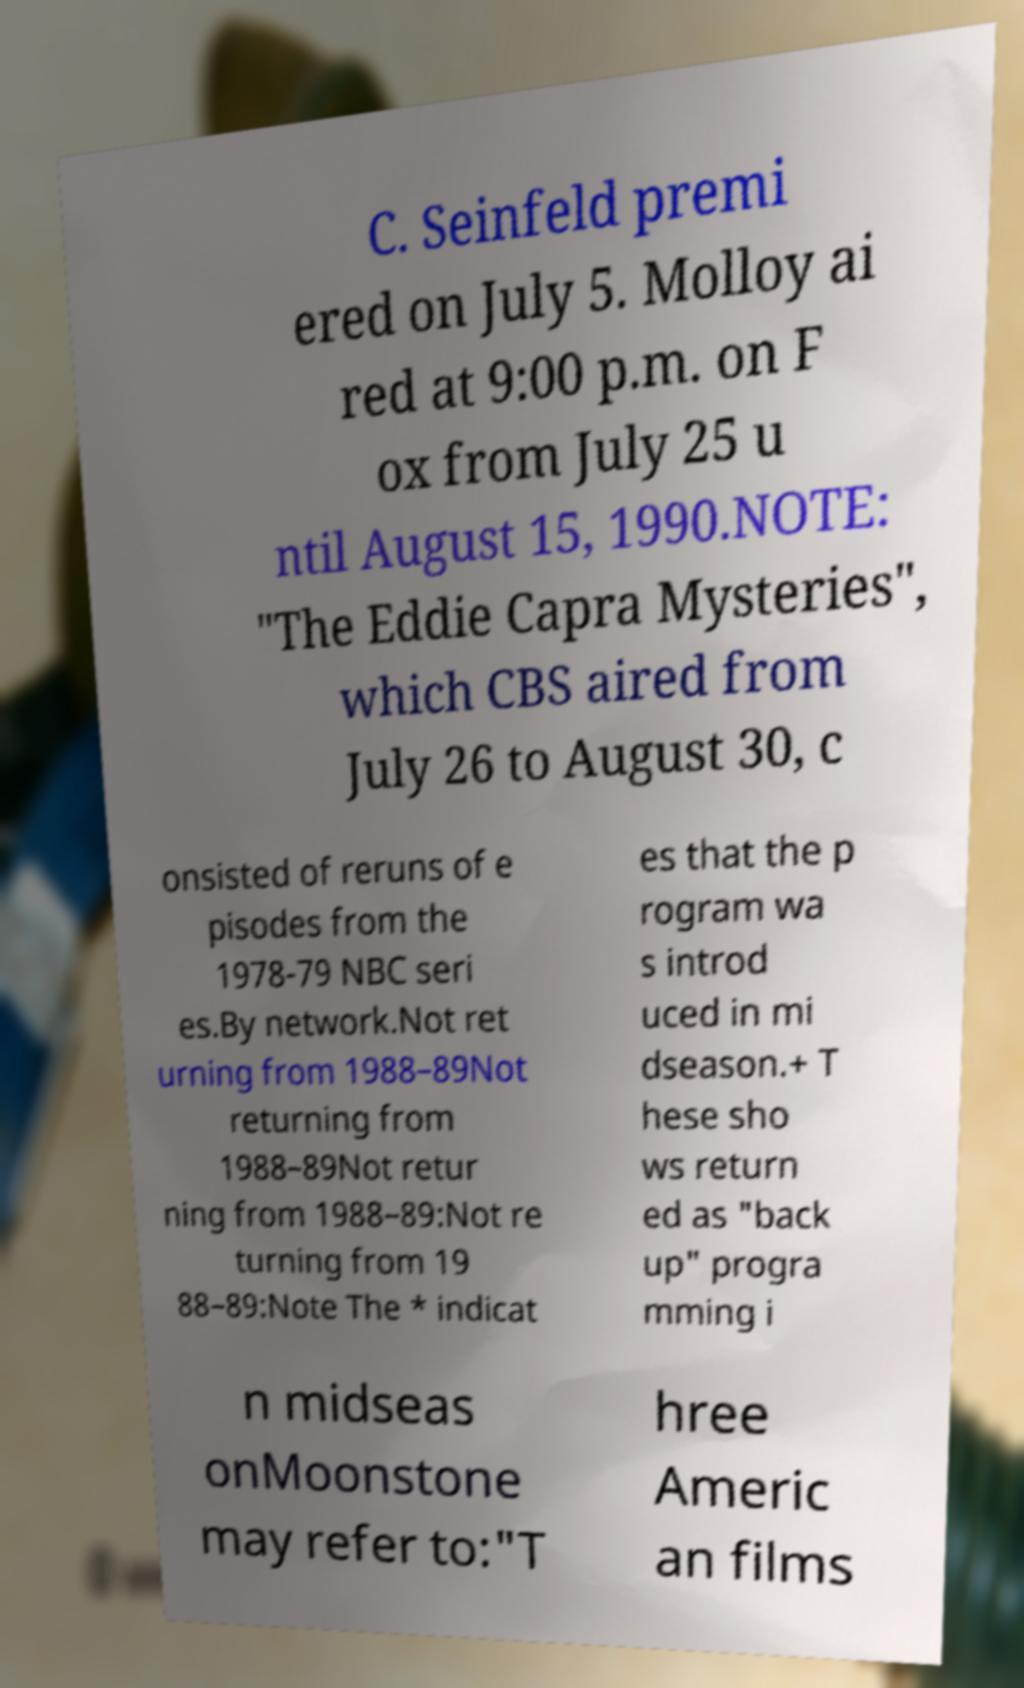Could you extract and type out the text from this image? C. Seinfeld premi ered on July 5. Molloy ai red at 9:00 p.m. on F ox from July 25 u ntil August 15, 1990.NOTE: "The Eddie Capra Mysteries", which CBS aired from July 26 to August 30, c onsisted of reruns of e pisodes from the 1978-79 NBC seri es.By network.Not ret urning from 1988–89Not returning from 1988–89Not retur ning from 1988–89:Not re turning from 19 88–89:Note The * indicat es that the p rogram wa s introd uced in mi dseason.+ T hese sho ws return ed as "back up" progra mming i n midseas onMoonstone may refer to:"T hree Americ an films 